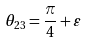Convert formula to latex. <formula><loc_0><loc_0><loc_500><loc_500>\theta _ { 2 3 } = \frac { \pi } { 4 } + \varepsilon</formula> 